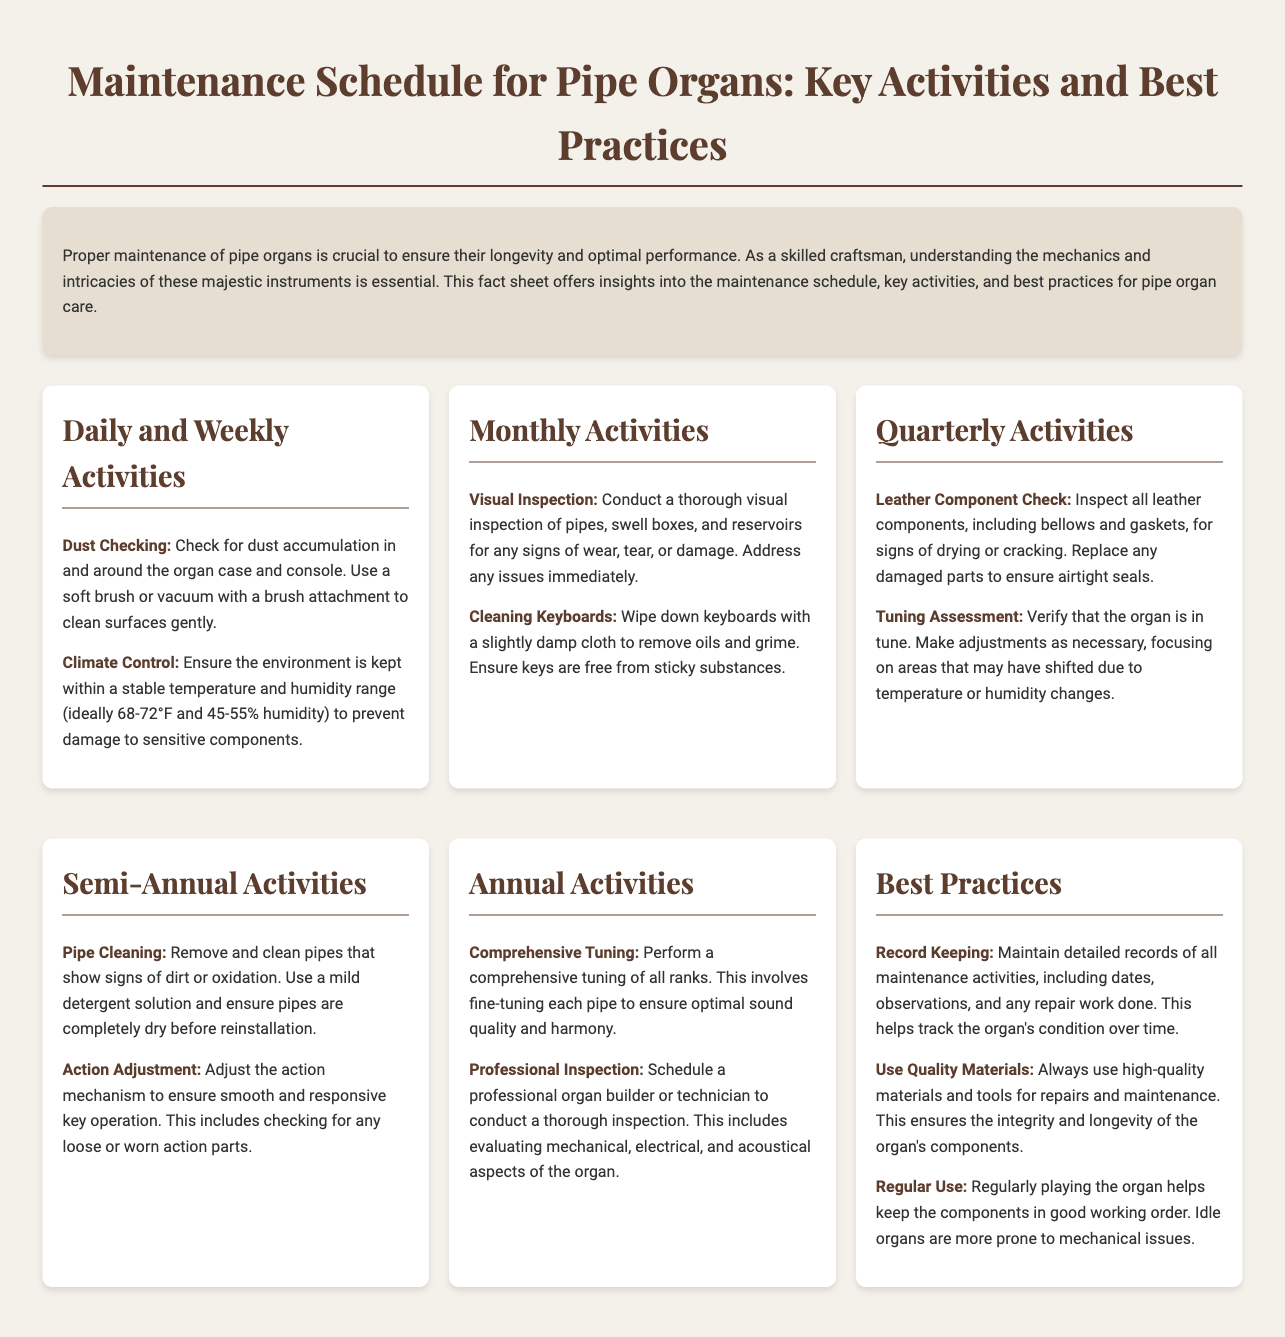What is the ideal humidity range for organ maintenance? The document states that the ideal humidity range is 45-55%.
Answer: 45-55% How often should a visual inspection of pipes be conducted? The fact sheet indicates that a visual inspection should be conducted monthly.
Answer: Monthly What activity involves cleaning the keys? The fact sheet specifies that cleaning keyboards is a monthly activity.
Answer: Cleaning Keyboards What is the recommended action for leather components? The document advises inspecting leather components for drying or cracking quarterly.
Answer: Inspecting How frequently should a comprehensive tuning of all ranks be performed? According to the fact sheet, a comprehensive tuning is performed annually.
Answer: Annually What is a best practice for organ maintenance? The fact sheet suggests regular use of the organ as a best practice.
Answer: Regular use What should be recorded during maintenance activities? The document highlights the importance of maintaining detailed records of all maintenance activities.
Answer: Detailed records How often should pipes be cleaned? The fact sheet states that pipes should be cleaned semi-annually.
Answer: Semi-annually What type of inspection should be scheduled annually? The document mentions that a professional inspection should be scheduled annually.
Answer: Professional inspection 